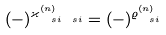<formula> <loc_0><loc_0><loc_500><loc_500>( - ) ^ { \varkappa ^ { ( n ) } _ { \ s { i } \ s { i } } } = ( - ) ^ { \varrho ^ { ( n ) } _ { \ s { i } } }</formula> 